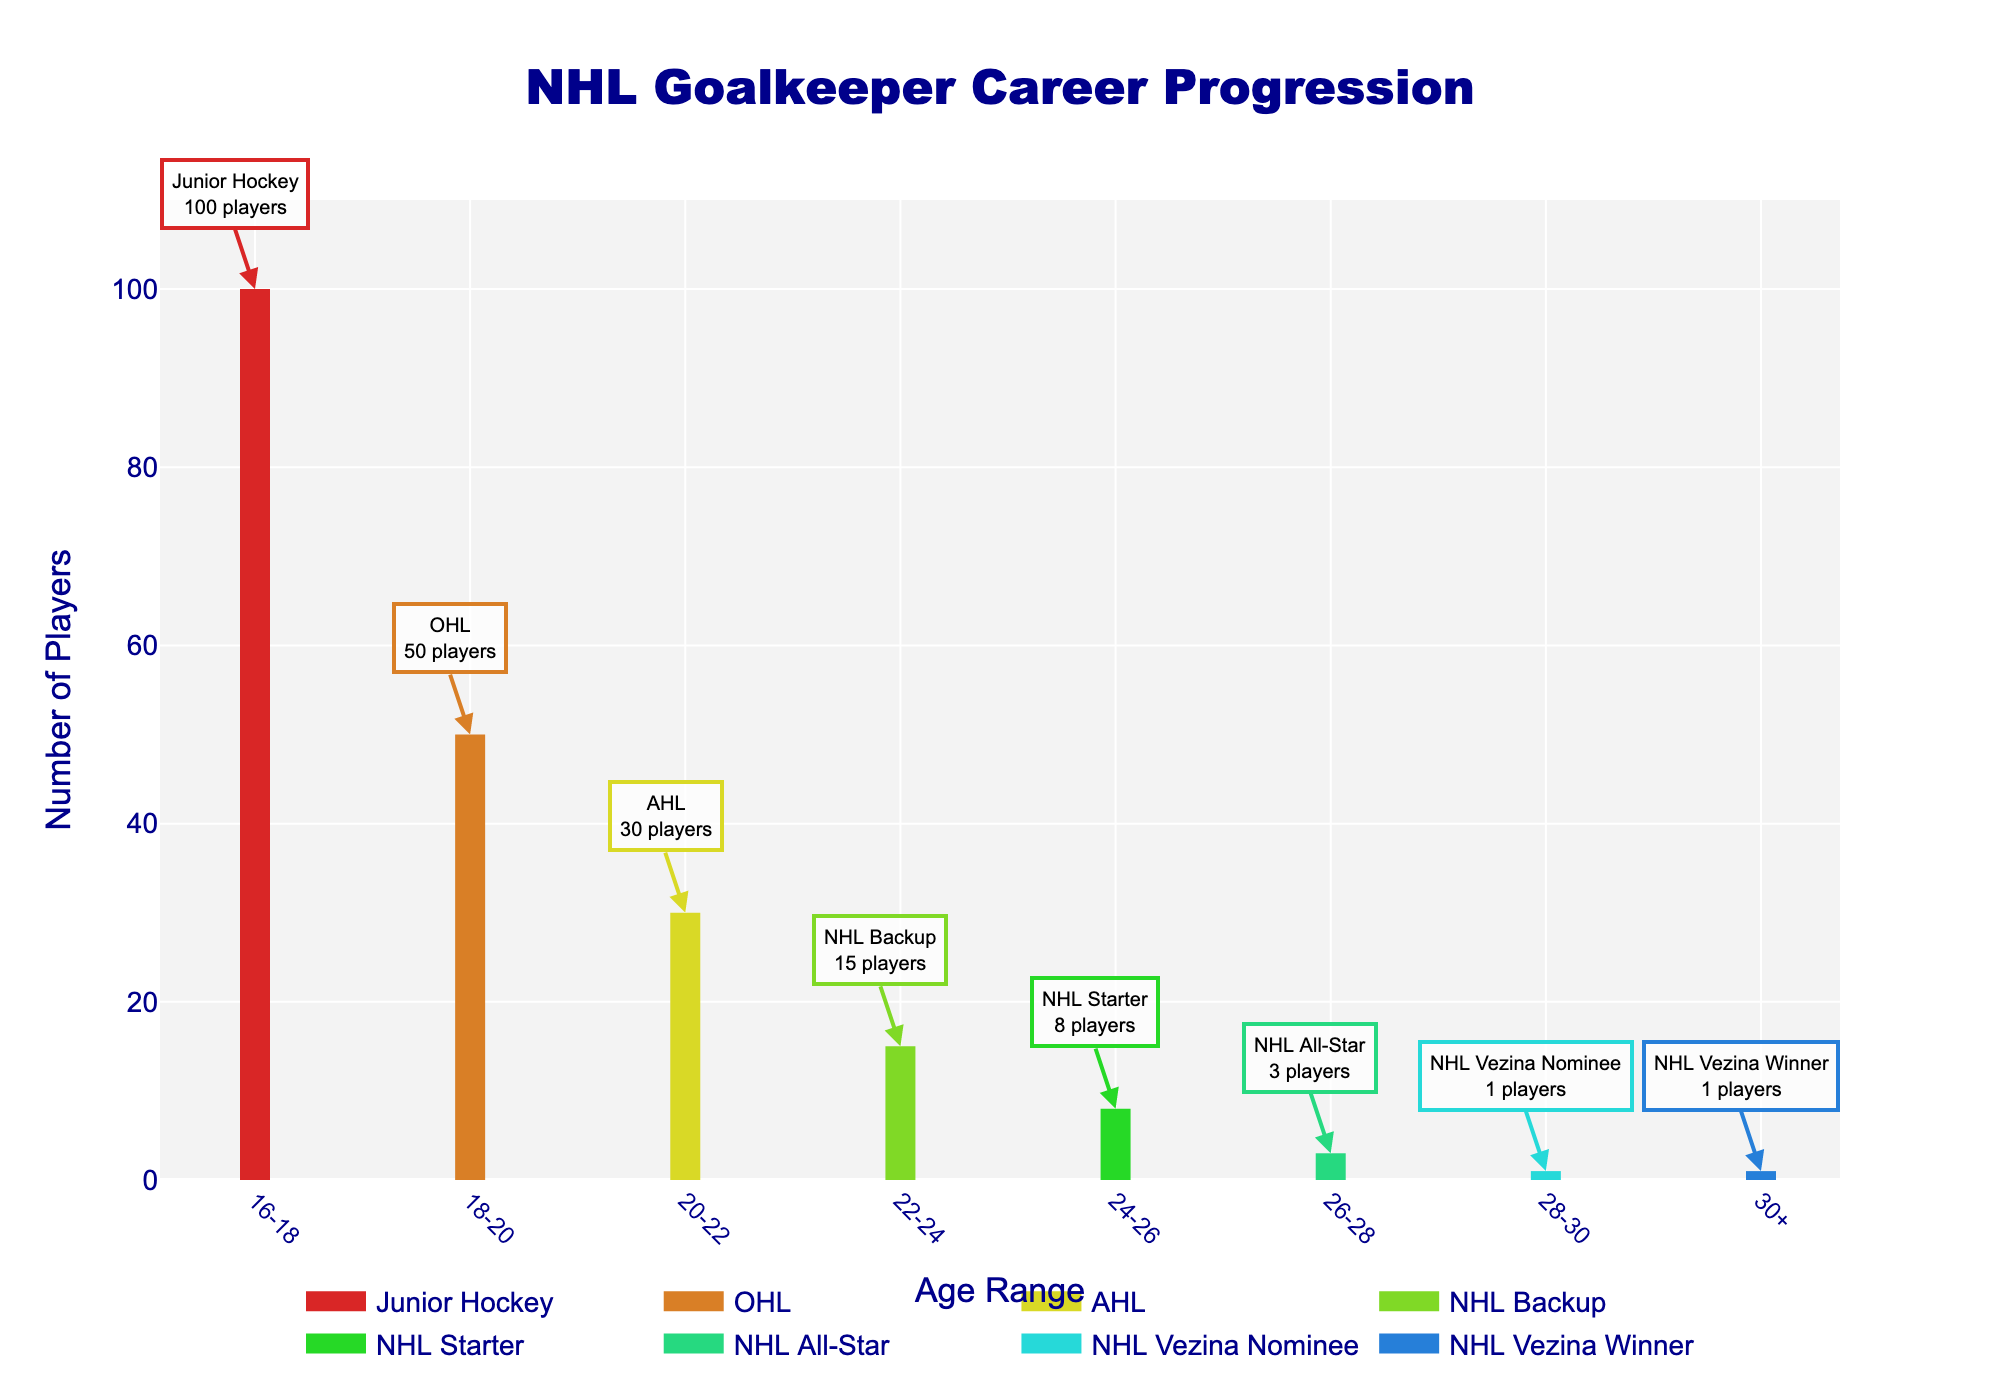What is the age range for Junior Hockey players? The figure shows the age ranges on the x-axis, and the specific range for Junior Hockey is labeled on the chart.
Answer: 16-18 How many players from Junior Hockey transition to the OHL? The chart shows that there are 100 players in Junior Hockey, and 50 players in the OHL. The difference gives the number of players making the transition.
Answer: 50 Which group has the highest number of players? By comparing the heights of the lines on the y-axis, Junior Hockey has the highest number of players with 100.
Answer: Junior Hockey Which group has the lowest number of players? By comparing the heights of the lines on the y-axis, both "NHL Vezina Nominee" and "NHL Vezina Winner" have the lowest number of players, with only 1 each.
Answer: NHL Vezina Nominee and NHL Vezina Winner What's the total number of players transitioning from the AHL to NHL positions (backup, starter, all-star, nominee, winner)? Summing the number of players from all NHL-related positions (15 + 8 + 3 + 1 + 1) gives the total.
Answer: 28 How does the number of players in the AHL compare to the OHL? By comparing the values, the OHL has 50 players, while the AHL has 30 players, indicating fewer players in the AHL.
Answer: The AHL has fewer players What is the average number of players across all groups? Summing the number of players (100 + 50 + 30 + 15 + 8 + 3 + 1 + 1) gives 208, and dividing by the number of groups (8) provides the average.
Answer: 26 Which age range corresponds to NHL Backups? The chart indicates age ranges on the x-axis, and NHL Backup is specifically labeled at 22-24 years.
Answer: 22-24 Is there any group with the same number of players as the NHL Starters? NHL Starters have 8 players, and by looking at the chart, no other group has exactly 8 players.
Answer: No 